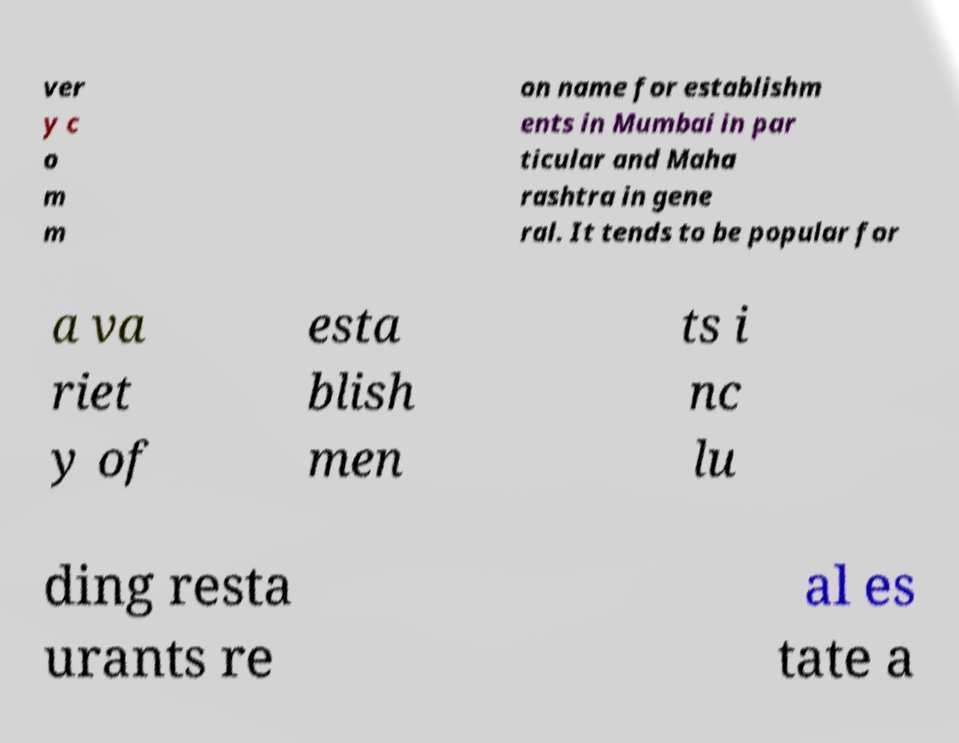There's text embedded in this image that I need extracted. Can you transcribe it verbatim? ver y c o m m on name for establishm ents in Mumbai in par ticular and Maha rashtra in gene ral. It tends to be popular for a va riet y of esta blish men ts i nc lu ding resta urants re al es tate a 